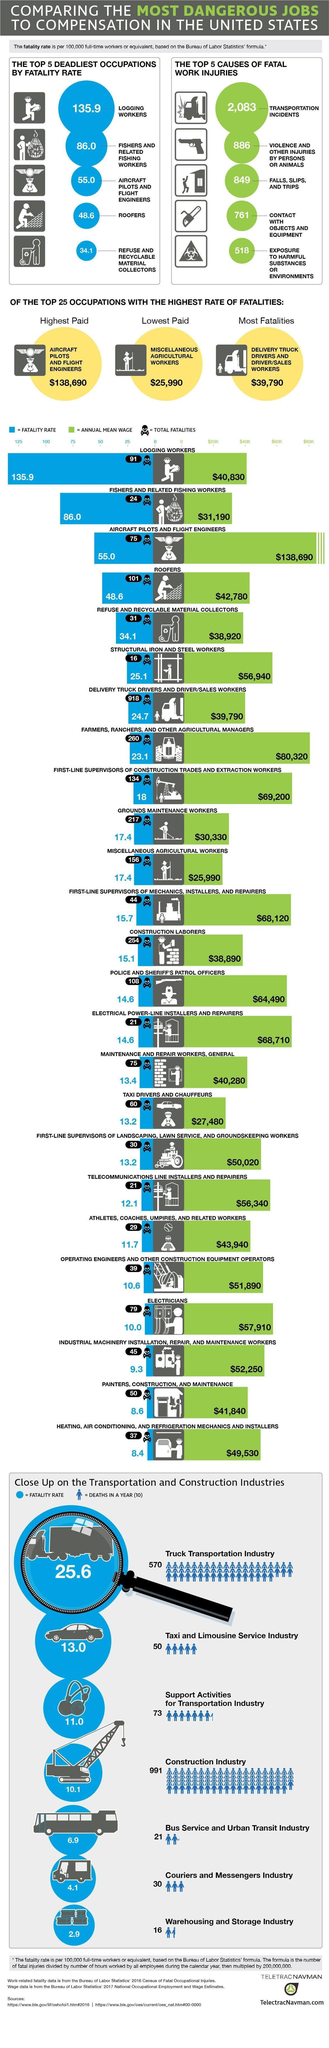Which occupation had highest total fatalities?
Answer the question with a short phrase. DELIVERY TRUCK DRIVERS AND DRIVER/SALES WORKERS What is the total fatality rate of grounds maintenance workers? 217 Which is the fifth cause of fatal work injury? EXPOSURE TO HARMFUL SUBSTANCES OR ENVIRONMENTS Which industry has lowest fatality rate? Warehousing and Storage Industry Which is the third top occupation that is deadly? AIRCRAFT PILOTS AND FLIGHT ENGINEERS What is the maximum number of deaths in Taxi and Limousine Service Industry 50 What is the annual mean wage of roofers? $42,780 What is the lowest paid group's wage? $25,990 Which industry has the maximum deaths in a year? Construction Industry What is the fatality rate of logging workers? 135.9 How is the fatality rate calculated? based on Bureau of Labor Statistics formula What is the fatality rate in Couriers and Messengers Industry? 4.1 